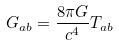Convert formula to latex. <formula><loc_0><loc_0><loc_500><loc_500>G _ { a b } = \frac { 8 \pi G } { c ^ { 4 } } T _ { a b }</formula> 